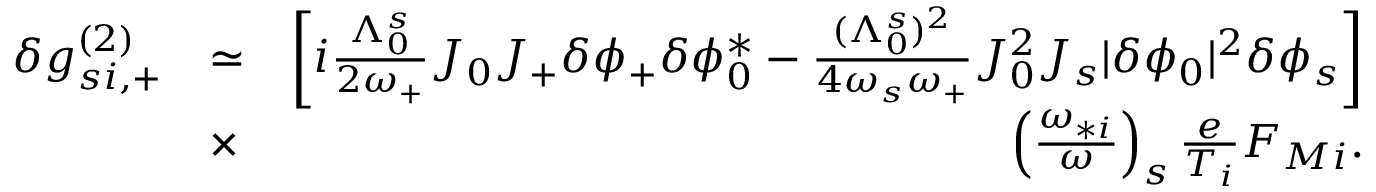Convert formula to latex. <formula><loc_0><loc_0><loc_500><loc_500>\begin{array} { r l r } { \delta g _ { s i , + } ^ { ( 2 ) } } & { \simeq } & { \left [ i \frac { \Lambda _ { 0 } ^ { s } } { 2 \omega _ { + } } J _ { 0 } J _ { + } \delta \phi _ { + } \delta \phi _ { 0 } ^ { * } - \frac { ( \Lambda _ { 0 } ^ { s } ) ^ { 2 } } { 4 \omega _ { s } \omega _ { + } } J _ { 0 } ^ { 2 } J _ { s } | \delta \phi _ { 0 } | ^ { 2 } \delta \phi _ { s } \right ] } \\ & { \times } & { \left ( \frac { \omega _ { * i } } { \omega } \right ) _ { s } \frac { e } { T _ { i } } F _ { M i } . } \end{array}</formula> 